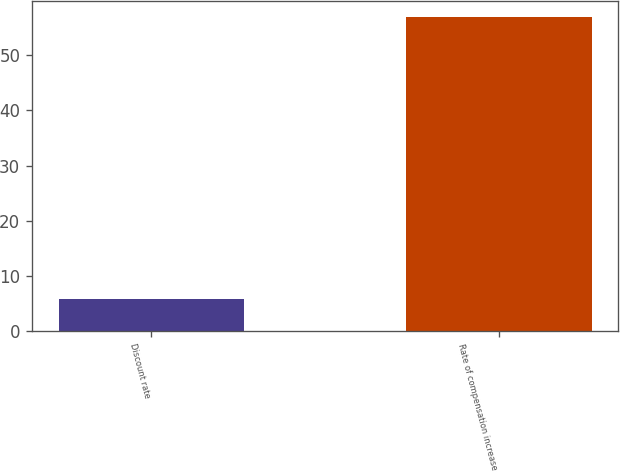<chart> <loc_0><loc_0><loc_500><loc_500><bar_chart><fcel>Discount rate<fcel>Rate of compensation increase<nl><fcel>5.75<fcel>57<nl></chart> 